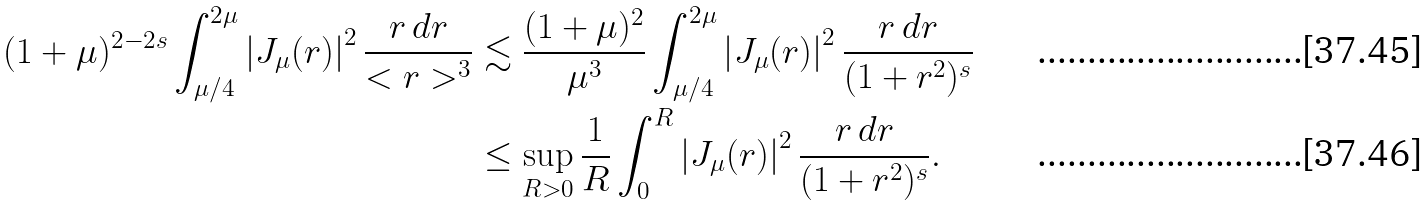<formula> <loc_0><loc_0><loc_500><loc_500>( 1 + \mu ) ^ { 2 - 2 s } \int _ { \mu / 4 } ^ { 2 \mu } \left | J _ { \mu } ( r ) \right | ^ { 2 } \frac { r \, d r } { < r > ^ { 3 } } & \lesssim \frac { ( 1 + \mu ) ^ { 2 } } { \mu ^ { 3 } } \int _ { \mu / 4 } ^ { 2 \mu } \left | J _ { \mu } ( r ) \right | ^ { 2 } \frac { r \, d r } { ( 1 + r ^ { 2 } ) ^ { s } } \\ & \leq \sup _ { R > 0 } \frac { 1 } { R } \int _ { 0 } ^ { R } \left | J _ { \mu } ( r ) \right | ^ { 2 } \frac { r \, d r } { ( 1 + r ^ { 2 } ) ^ { s } } .</formula> 